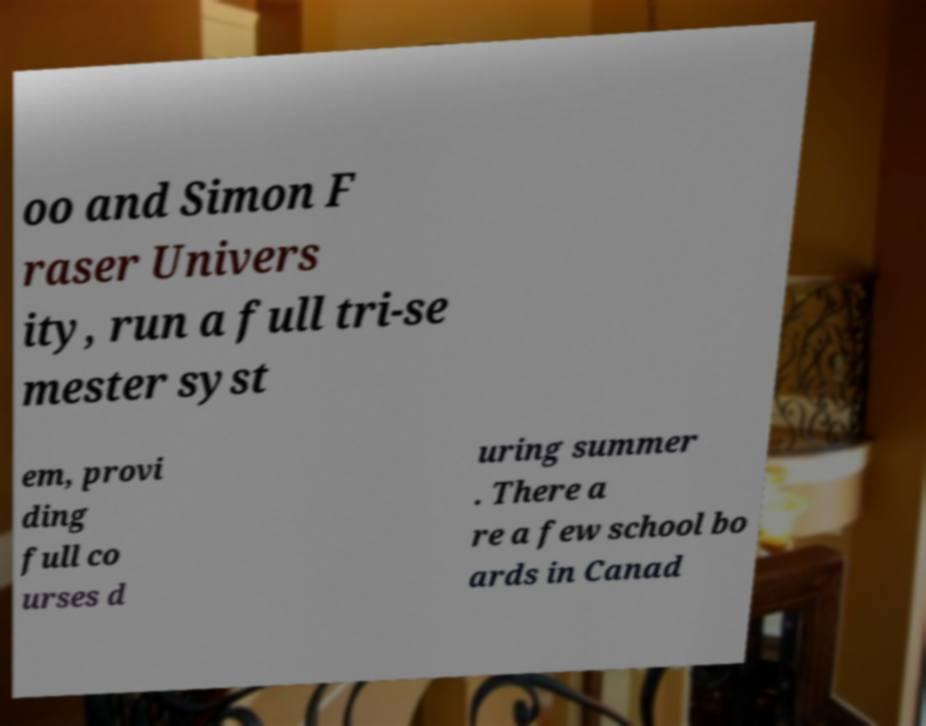There's text embedded in this image that I need extracted. Can you transcribe it verbatim? oo and Simon F raser Univers ity, run a full tri-se mester syst em, provi ding full co urses d uring summer . There a re a few school bo ards in Canad 